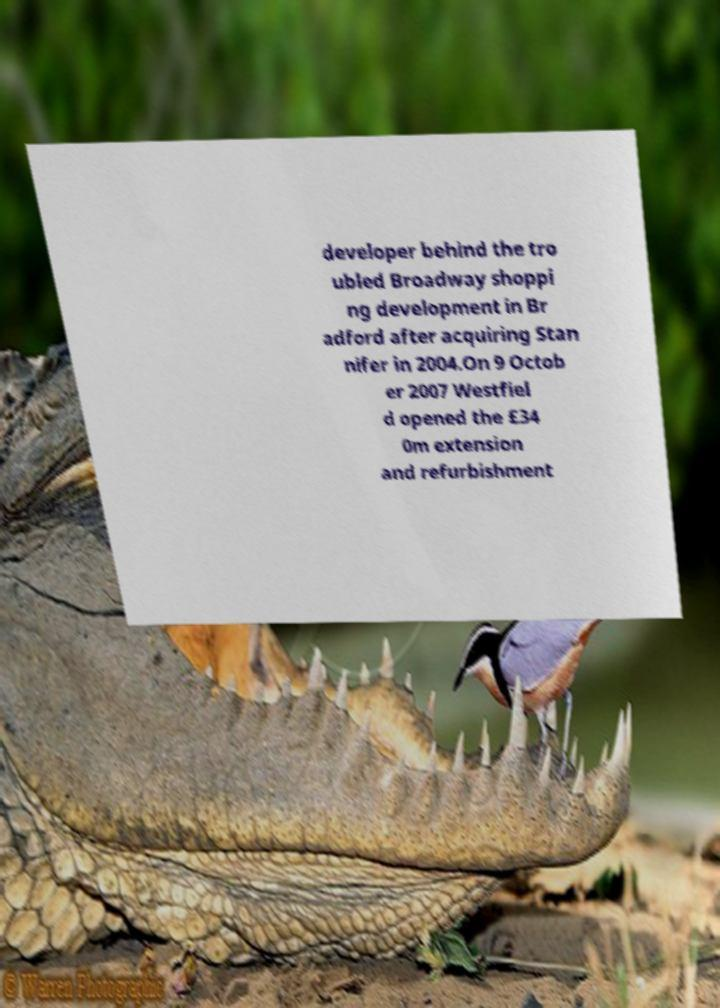There's text embedded in this image that I need extracted. Can you transcribe it verbatim? developer behind the tro ubled Broadway shoppi ng development in Br adford after acquiring Stan nifer in 2004.On 9 Octob er 2007 Westfiel d opened the £34 0m extension and refurbishment 